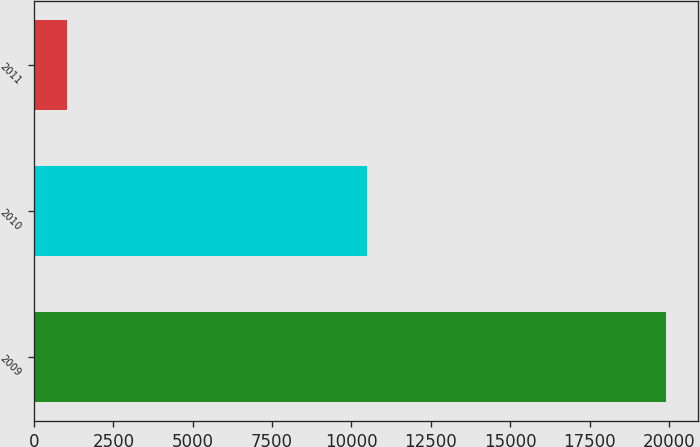<chart> <loc_0><loc_0><loc_500><loc_500><bar_chart><fcel>2009<fcel>2010<fcel>2011<nl><fcel>19913<fcel>10477<fcel>1042<nl></chart> 